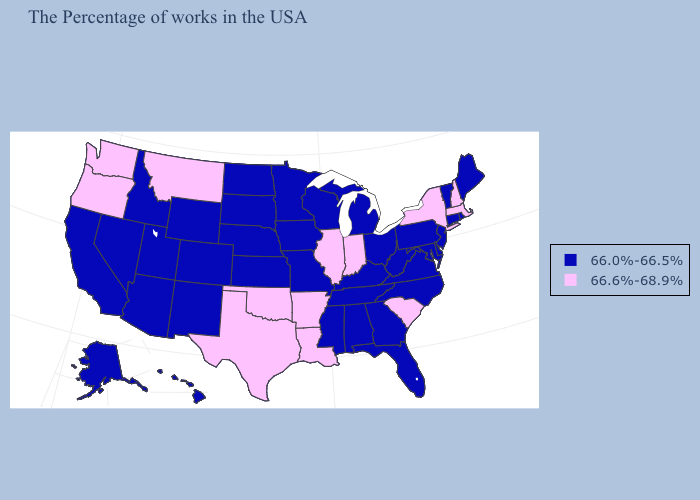Among the states that border Texas , which have the highest value?
Write a very short answer. Louisiana, Arkansas, Oklahoma. Among the states that border Kansas , does Oklahoma have the highest value?
Write a very short answer. Yes. Does Colorado have the highest value in the USA?
Short answer required. No. Which states have the lowest value in the Northeast?
Concise answer only. Maine, Rhode Island, Vermont, Connecticut, New Jersey, Pennsylvania. What is the lowest value in states that border New York?
Give a very brief answer. 66.0%-66.5%. Name the states that have a value in the range 66.6%-68.9%?
Be succinct. Massachusetts, New Hampshire, New York, South Carolina, Indiana, Illinois, Louisiana, Arkansas, Oklahoma, Texas, Montana, Washington, Oregon. What is the highest value in the South ?
Concise answer only. 66.6%-68.9%. Does Arkansas have the highest value in the USA?
Give a very brief answer. Yes. What is the value of Wisconsin?
Quick response, please. 66.0%-66.5%. Which states hav the highest value in the MidWest?
Keep it brief. Indiana, Illinois. Name the states that have a value in the range 66.0%-66.5%?
Be succinct. Maine, Rhode Island, Vermont, Connecticut, New Jersey, Delaware, Maryland, Pennsylvania, Virginia, North Carolina, West Virginia, Ohio, Florida, Georgia, Michigan, Kentucky, Alabama, Tennessee, Wisconsin, Mississippi, Missouri, Minnesota, Iowa, Kansas, Nebraska, South Dakota, North Dakota, Wyoming, Colorado, New Mexico, Utah, Arizona, Idaho, Nevada, California, Alaska, Hawaii. Name the states that have a value in the range 66.6%-68.9%?
Write a very short answer. Massachusetts, New Hampshire, New York, South Carolina, Indiana, Illinois, Louisiana, Arkansas, Oklahoma, Texas, Montana, Washington, Oregon. Name the states that have a value in the range 66.0%-66.5%?
Keep it brief. Maine, Rhode Island, Vermont, Connecticut, New Jersey, Delaware, Maryland, Pennsylvania, Virginia, North Carolina, West Virginia, Ohio, Florida, Georgia, Michigan, Kentucky, Alabama, Tennessee, Wisconsin, Mississippi, Missouri, Minnesota, Iowa, Kansas, Nebraska, South Dakota, North Dakota, Wyoming, Colorado, New Mexico, Utah, Arizona, Idaho, Nevada, California, Alaska, Hawaii. What is the value of Arkansas?
Keep it brief. 66.6%-68.9%. 